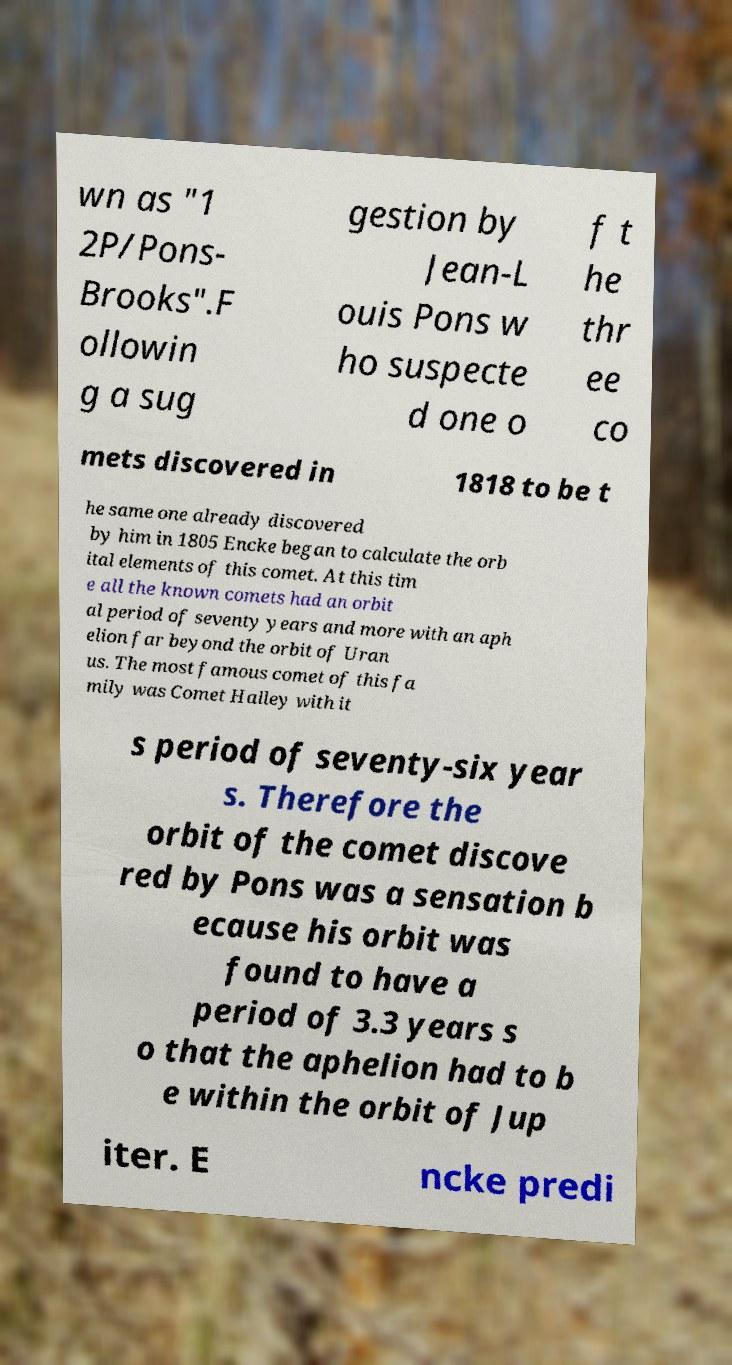What messages or text are displayed in this image? I need them in a readable, typed format. wn as "1 2P/Pons- Brooks".F ollowin g a sug gestion by Jean-L ouis Pons w ho suspecte d one o f t he thr ee co mets discovered in 1818 to be t he same one already discovered by him in 1805 Encke began to calculate the orb ital elements of this comet. At this tim e all the known comets had an orbit al period of seventy years and more with an aph elion far beyond the orbit of Uran us. The most famous comet of this fa mily was Comet Halley with it s period of seventy-six year s. Therefore the orbit of the comet discove red by Pons was a sensation b ecause his orbit was found to have a period of 3.3 years s o that the aphelion had to b e within the orbit of Jup iter. E ncke predi 